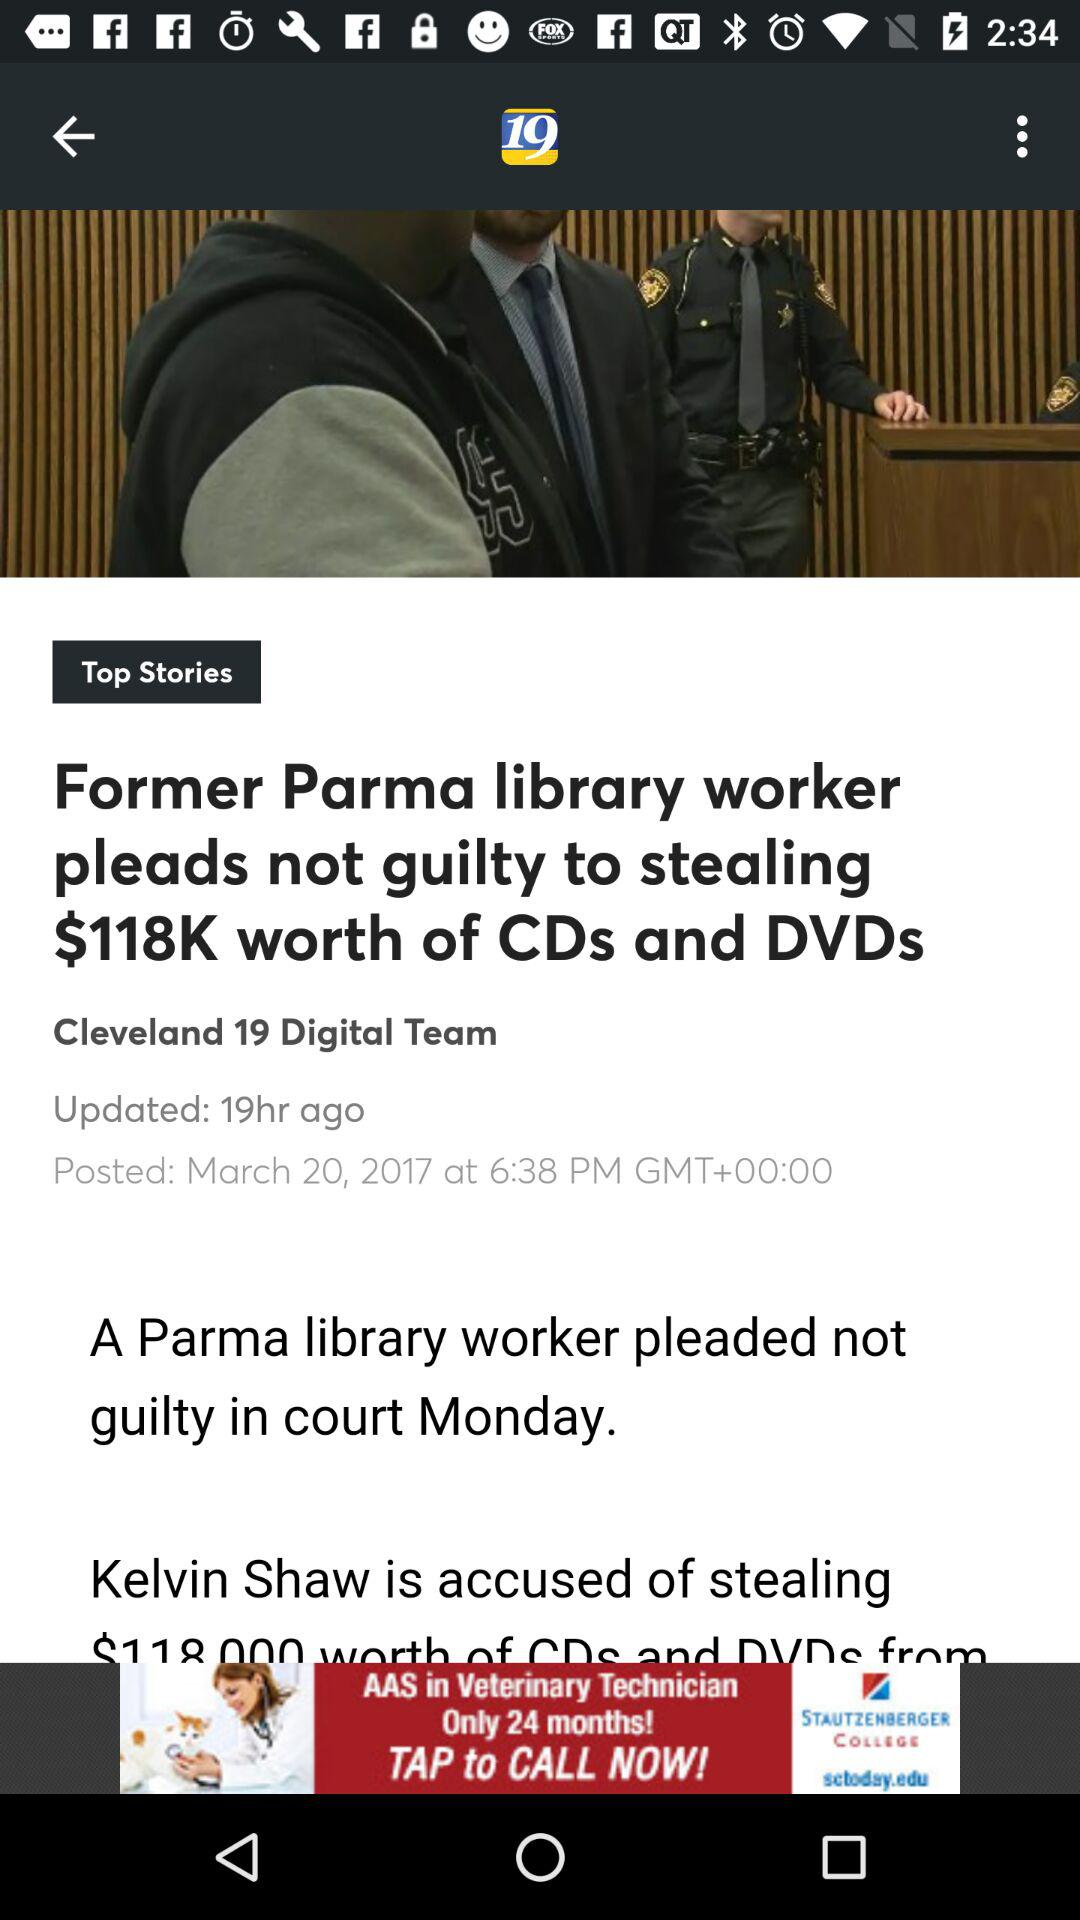How many hours ago was the article posted?
Answer the question using a single word or phrase. 19 